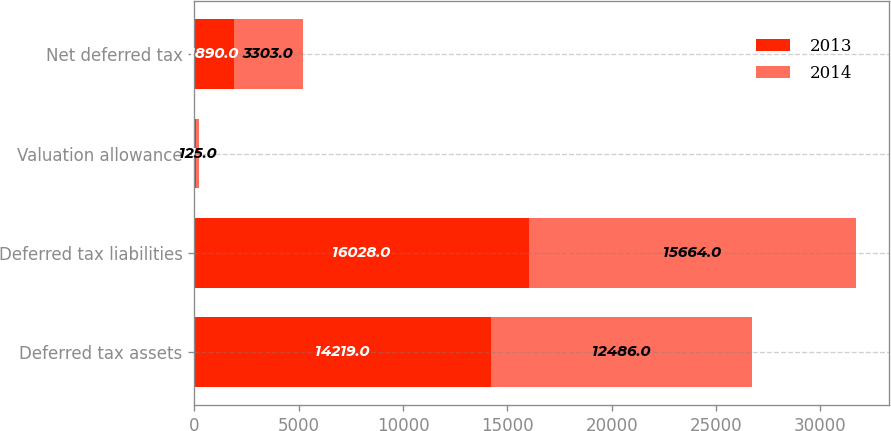Convert chart to OTSL. <chart><loc_0><loc_0><loc_500><loc_500><stacked_bar_chart><ecel><fcel>Deferred tax assets<fcel>Deferred tax liabilities<fcel>Valuation allowance<fcel>Net deferred tax<nl><fcel>2013<fcel>14219<fcel>16028<fcel>81<fcel>1890<nl><fcel>2014<fcel>12486<fcel>15664<fcel>125<fcel>3303<nl></chart> 